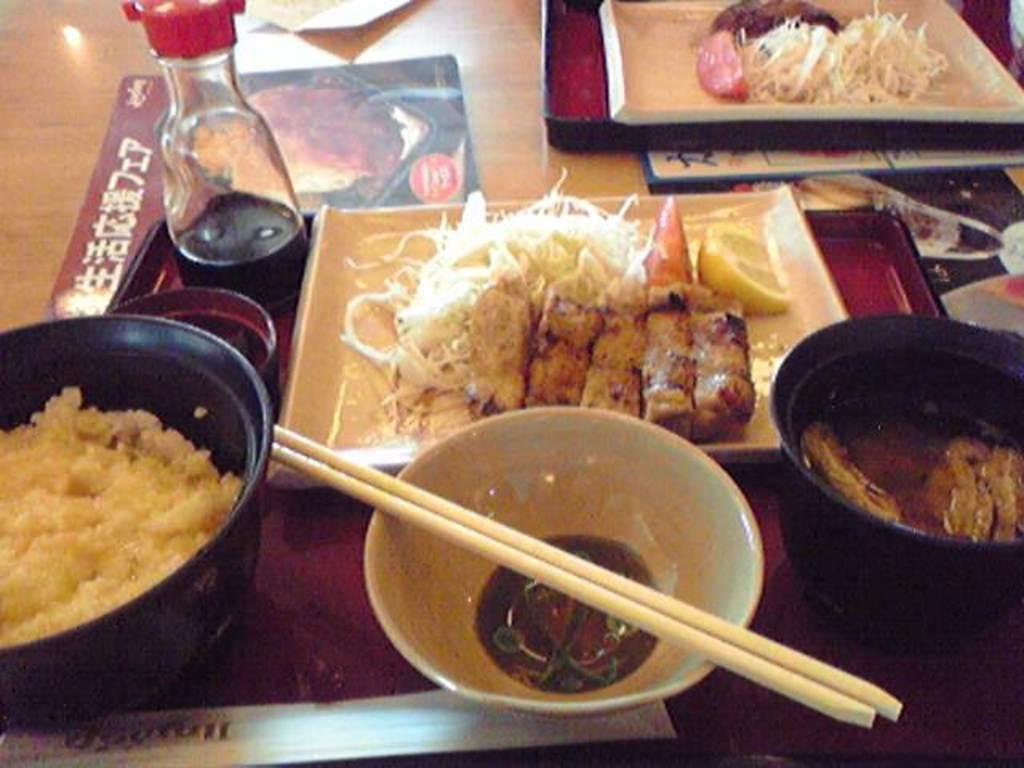What is in the bowl that is visible in the image? There is food on a plate in the image. What utensils are present in the image? There are chopsticks in the image. What type of container is visible in the image? There is a bottle in the image. What surface is the food and chopsticks placed on? There is a table in the image. What additional item can be seen on the table? There is a paper in the image. Can you tell me how many cats are sitting on the table in the image? There are no cats present in the image. What type of fruit is visible on the plate in the image? There is no fruit visible on the plate in the image; it contains food, but the specific type of food is not mentioned. 